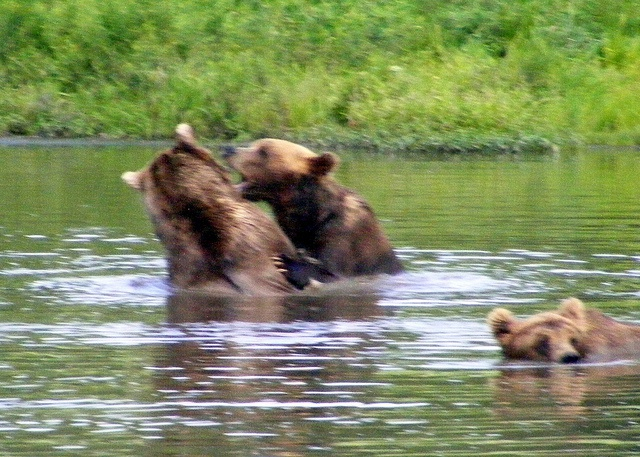Describe the objects in this image and their specific colors. I can see bear in green, black, gray, and maroon tones, bear in green, black, gray, and maroon tones, and bear in green, gray, tan, and darkgray tones in this image. 